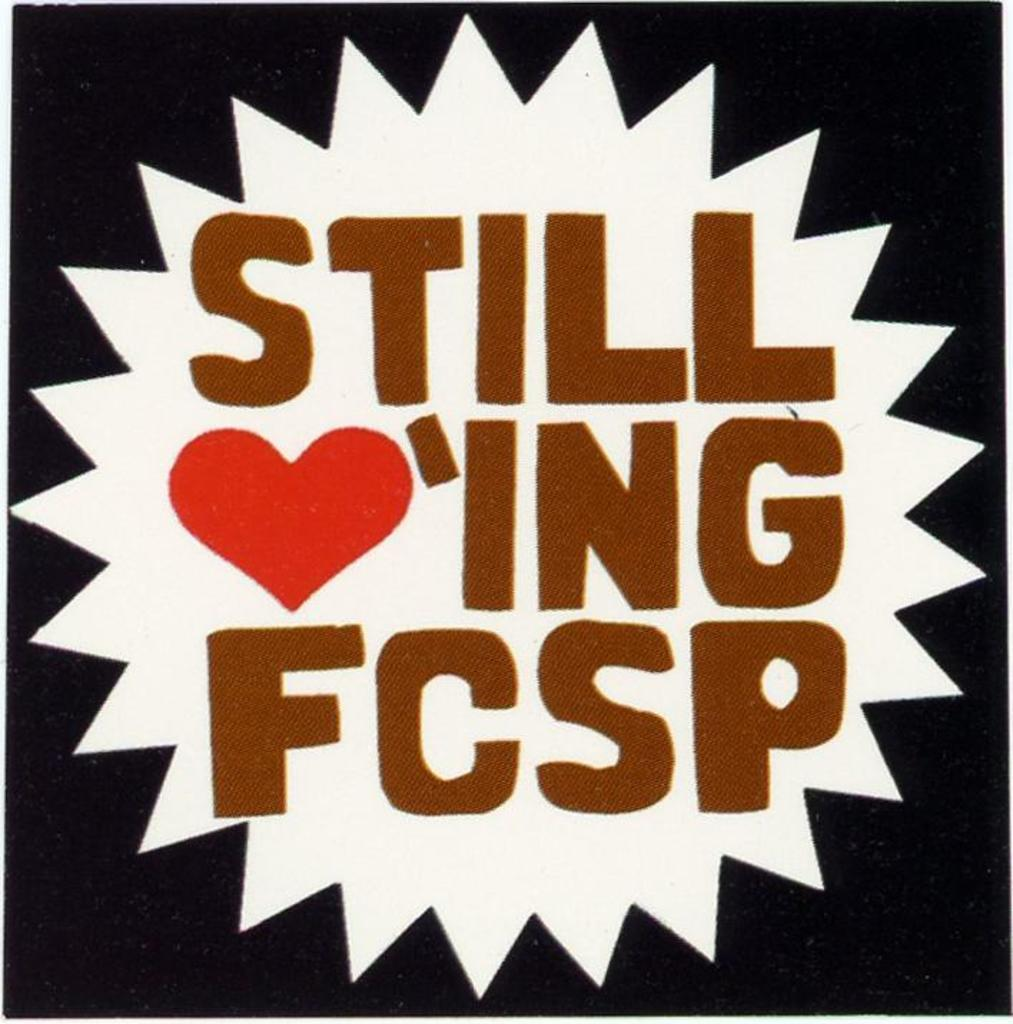Provide a one-sentence caption for the provided image. A poster that says Still Lov'ing FCSP, with the letters LOV replaced with a red heart symbol. 